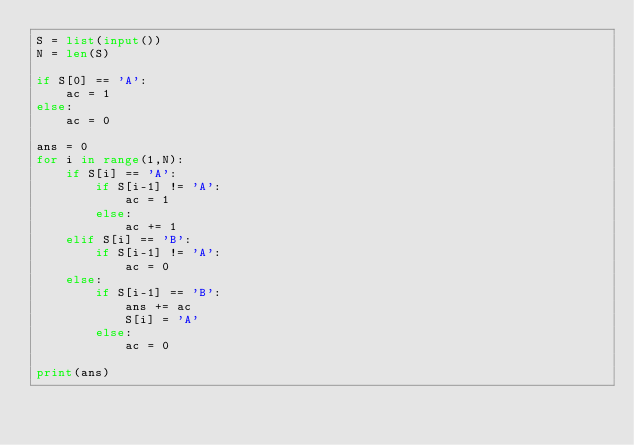<code> <loc_0><loc_0><loc_500><loc_500><_Python_>S = list(input())
N = len(S)

if S[0] == 'A':
    ac = 1
else:
    ac = 0

ans = 0
for i in range(1,N):
    if S[i] == 'A':
        if S[i-1] != 'A':
            ac = 1
        else:
            ac += 1
    elif S[i] == 'B':
        if S[i-1] != 'A':
            ac = 0
    else:
        if S[i-1] == 'B':
            ans += ac
            S[i] = 'A'
        else:
            ac = 0

print(ans)

</code> 